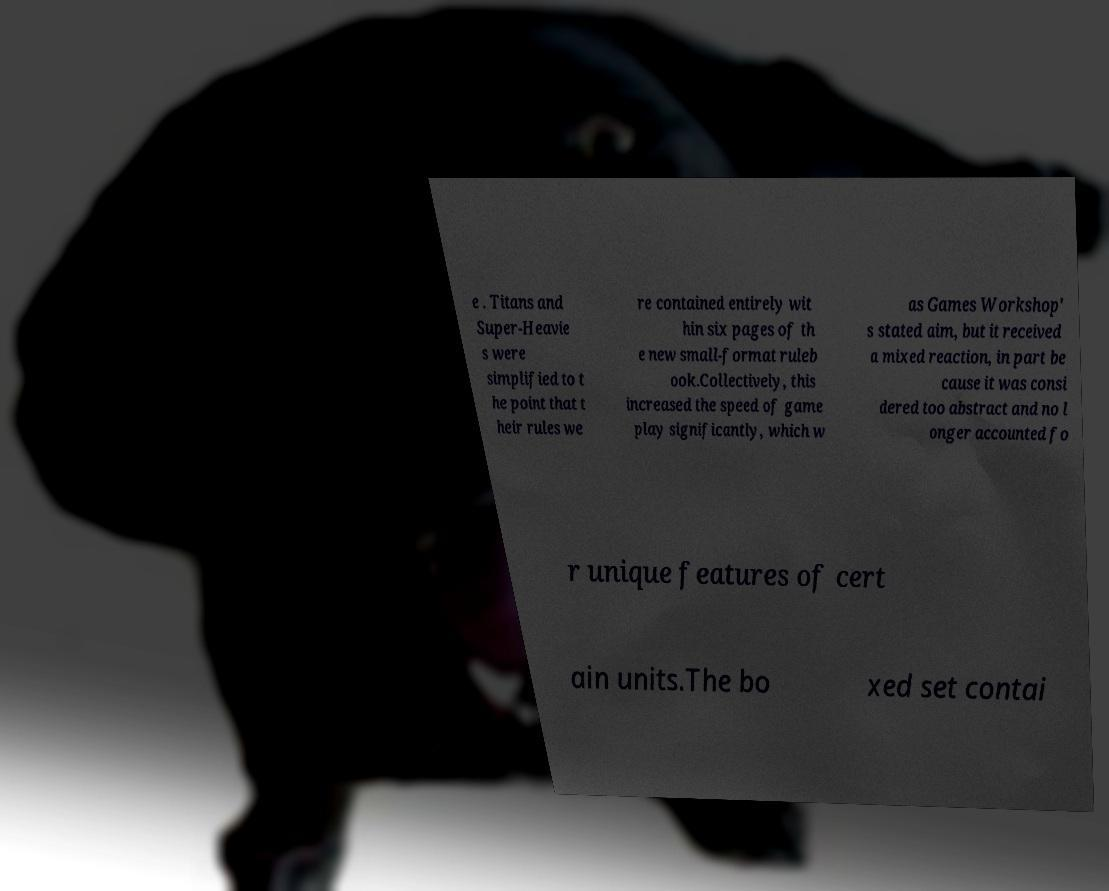I need the written content from this picture converted into text. Can you do that? e . Titans and Super-Heavie s were simplified to t he point that t heir rules we re contained entirely wit hin six pages of th e new small-format ruleb ook.Collectively, this increased the speed of game play significantly, which w as Games Workshop' s stated aim, but it received a mixed reaction, in part be cause it was consi dered too abstract and no l onger accounted fo r unique features of cert ain units.The bo xed set contai 